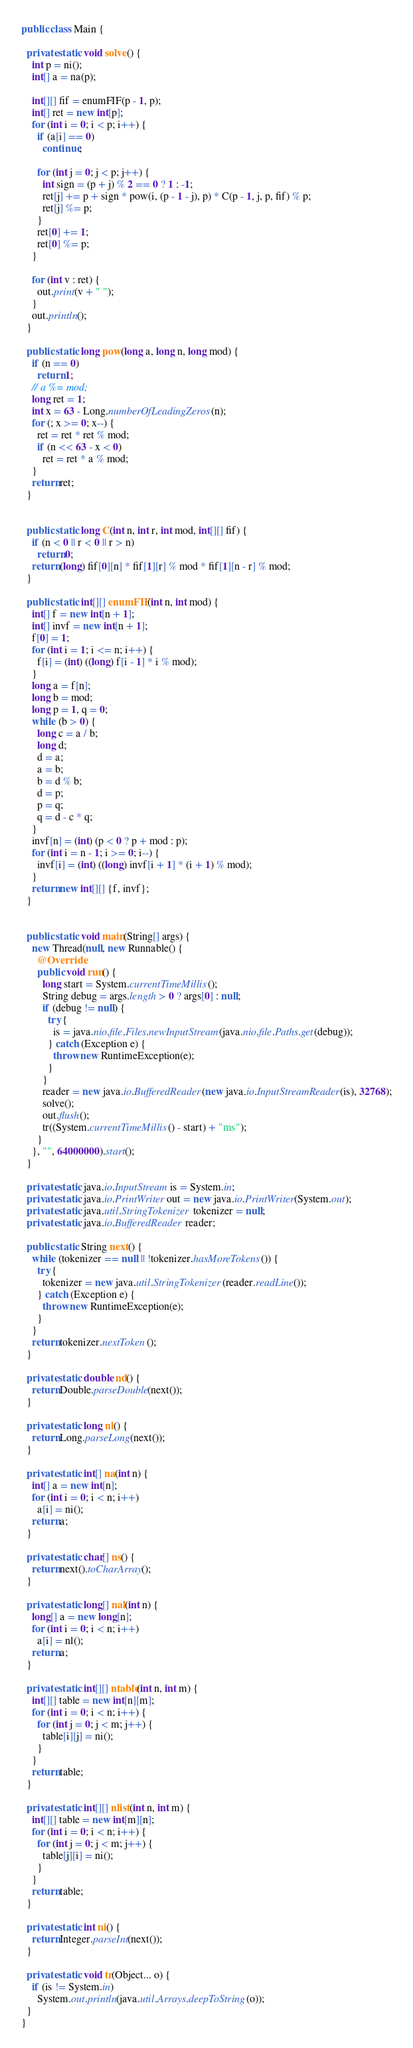Convert code to text. <code><loc_0><loc_0><loc_500><loc_500><_Java_>
public class Main {

  private static void solve() {
    int p = ni();
    int[] a = na(p);

    int[][] fif = enumFIF(p - 1, p);
    int[] ret = new int[p];
    for (int i = 0; i < p; i++) {
      if (a[i] == 0)
        continue;

      for (int j = 0; j < p; j++) {
        int sign = (p + j) % 2 == 0 ? 1 : -1;
        ret[j] += p + sign * pow(i, (p - 1 - j), p) * C(p - 1, j, p, fif) % p;
        ret[j] %= p;
      }
      ret[0] += 1;
      ret[0] %= p;
    }

    for (int v : ret) {
      out.print(v + " ");
    }
    out.println();
  }

  public static long pow(long a, long n, long mod) {
    if (n == 0)
      return 1;
    // a %= mod;
    long ret = 1;
    int x = 63 - Long.numberOfLeadingZeros(n);
    for (; x >= 0; x--) {
      ret = ret * ret % mod;
      if (n << 63 - x < 0)
        ret = ret * a % mod;
    }
    return ret;
  }


  public static long C(int n, int r, int mod, int[][] fif) {
    if (n < 0 || r < 0 || r > n)
      return 0;
    return (long) fif[0][n] * fif[1][r] % mod * fif[1][n - r] % mod;
  }

  public static int[][] enumFIF(int n, int mod) {
    int[] f = new int[n + 1];
    int[] invf = new int[n + 1];
    f[0] = 1;
    for (int i = 1; i <= n; i++) {
      f[i] = (int) ((long) f[i - 1] * i % mod);
    }
    long a = f[n];
    long b = mod;
    long p = 1, q = 0;
    while (b > 0) {
      long c = a / b;
      long d;
      d = a;
      a = b;
      b = d % b;
      d = p;
      p = q;
      q = d - c * q;
    }
    invf[n] = (int) (p < 0 ? p + mod : p);
    for (int i = n - 1; i >= 0; i--) {
      invf[i] = (int) ((long) invf[i + 1] * (i + 1) % mod);
    }
    return new int[][] {f, invf};
  }


  public static void main(String[] args) {
    new Thread(null, new Runnable() {
      @Override
      public void run() {
        long start = System.currentTimeMillis();
        String debug = args.length > 0 ? args[0] : null;
        if (debug != null) {
          try {
            is = java.nio.file.Files.newInputStream(java.nio.file.Paths.get(debug));
          } catch (Exception e) {
            throw new RuntimeException(e);
          }
        }
        reader = new java.io.BufferedReader(new java.io.InputStreamReader(is), 32768);
        solve();
        out.flush();
        tr((System.currentTimeMillis() - start) + "ms");
      }
    }, "", 64000000).start();
  }

  private static java.io.InputStream is = System.in;
  private static java.io.PrintWriter out = new java.io.PrintWriter(System.out);
  private static java.util.StringTokenizer tokenizer = null;
  private static java.io.BufferedReader reader;

  public static String next() {
    while (tokenizer == null || !tokenizer.hasMoreTokens()) {
      try {
        tokenizer = new java.util.StringTokenizer(reader.readLine());
      } catch (Exception e) {
        throw new RuntimeException(e);
      }
    }
    return tokenizer.nextToken();
  }

  private static double nd() {
    return Double.parseDouble(next());
  }

  private static long nl() {
    return Long.parseLong(next());
  }

  private static int[] na(int n) {
    int[] a = new int[n];
    for (int i = 0; i < n; i++)
      a[i] = ni();
    return a;
  }

  private static char[] ns() {
    return next().toCharArray();
  }

  private static long[] nal(int n) {
    long[] a = new long[n];
    for (int i = 0; i < n; i++)
      a[i] = nl();
    return a;
  }

  private static int[][] ntable(int n, int m) {
    int[][] table = new int[n][m];
    for (int i = 0; i < n; i++) {
      for (int j = 0; j < m; j++) {
        table[i][j] = ni();
      }
    }
    return table;
  }

  private static int[][] nlist(int n, int m) {
    int[][] table = new int[m][n];
    for (int i = 0; i < n; i++) {
      for (int j = 0; j < m; j++) {
        table[j][i] = ni();
      }
    }
    return table;
  }

  private static int ni() {
    return Integer.parseInt(next());
  }

  private static void tr(Object... o) {
    if (is != System.in)
      System.out.println(java.util.Arrays.deepToString(o));
  }
}

</code> 